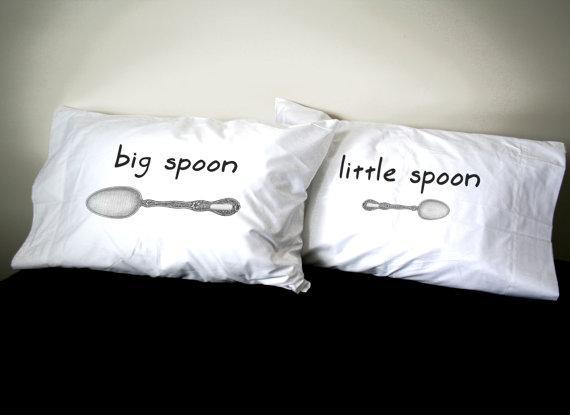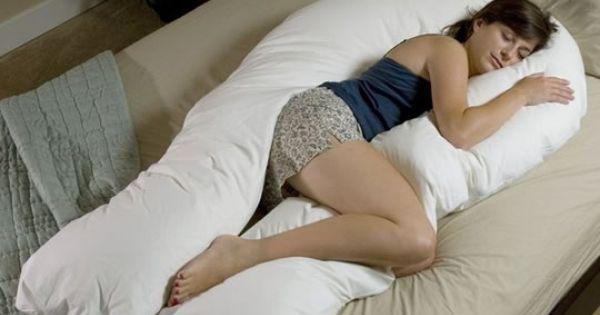The first image is the image on the left, the second image is the image on the right. Assess this claim about the two images: "Some of the pillows mention spoons.". Correct or not? Answer yes or no. Yes. 